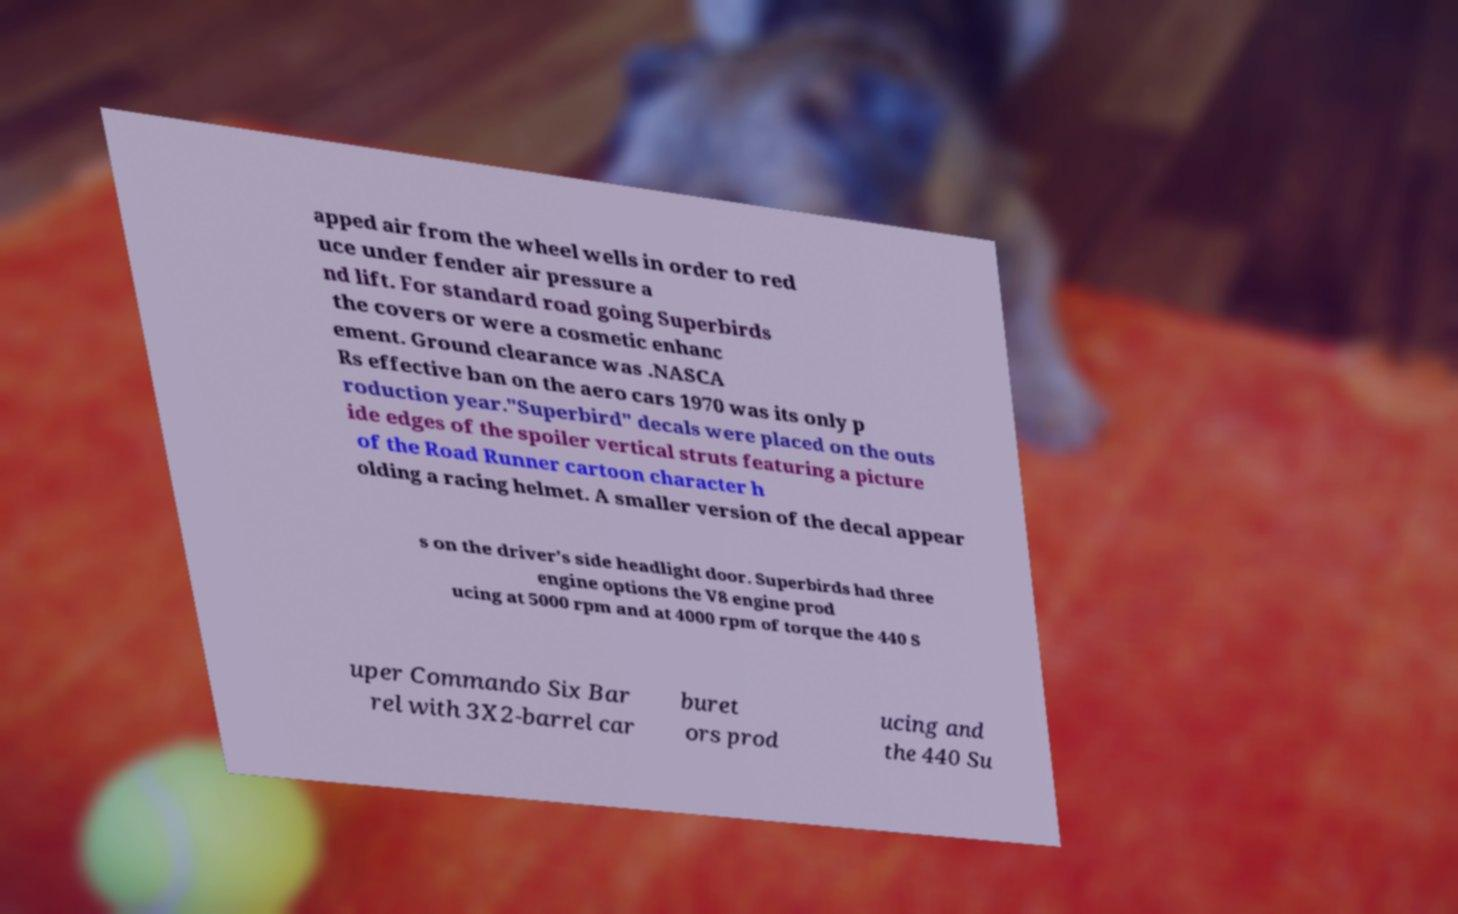For documentation purposes, I need the text within this image transcribed. Could you provide that? apped air from the wheel wells in order to red uce under fender air pressure a nd lift. For standard road going Superbirds the covers or were a cosmetic enhanc ement. Ground clearance was .NASCA Rs effective ban on the aero cars 1970 was its only p roduction year."Superbird" decals were placed on the outs ide edges of the spoiler vertical struts featuring a picture of the Road Runner cartoon character h olding a racing helmet. A smaller version of the decal appear s on the driver's side headlight door. Superbirds had three engine options the V8 engine prod ucing at 5000 rpm and at 4000 rpm of torque the 440 S uper Commando Six Bar rel with 3X2-barrel car buret ors prod ucing and the 440 Su 